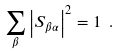Convert formula to latex. <formula><loc_0><loc_0><loc_500><loc_500>\sum _ { \beta } \left | S _ { \beta \alpha } \right | ^ { 2 } = 1 \ .</formula> 